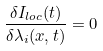<formula> <loc_0><loc_0><loc_500><loc_500>\frac { \delta I _ { l o c } ( t ) } { \delta \lambda _ { i } ( x , t ) } = 0</formula> 